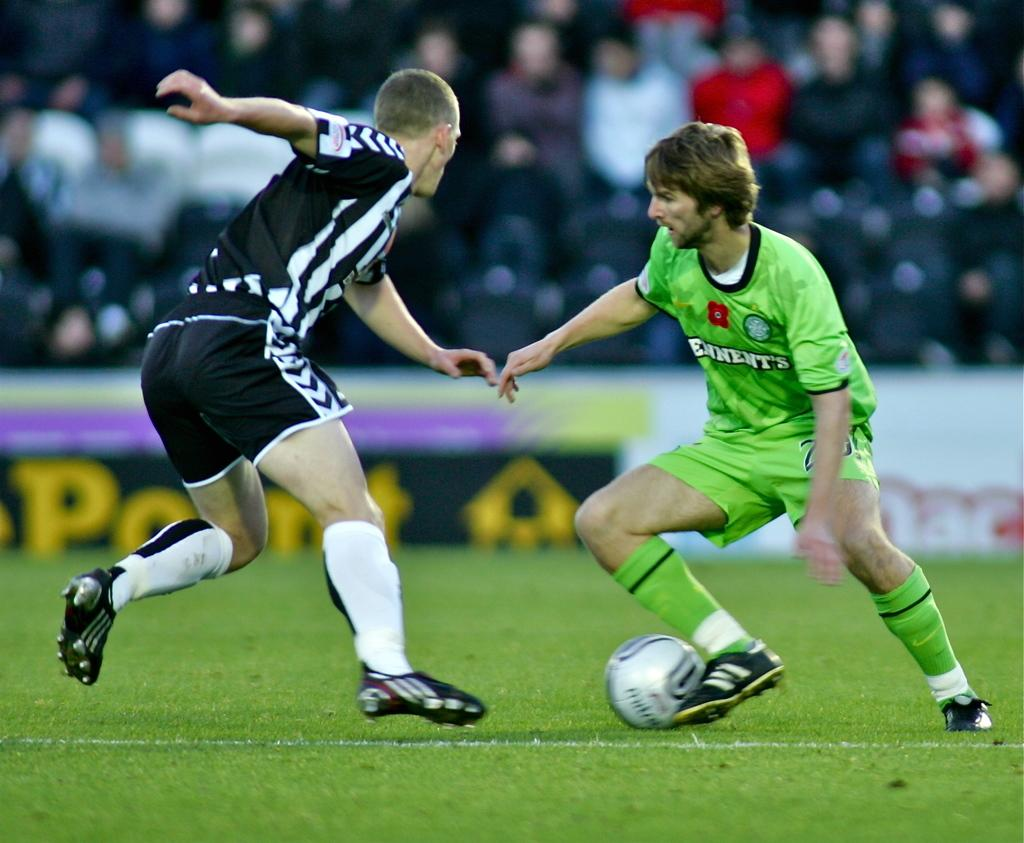How many players are in the image? There are two players in the image. What sport are the players engaged in? The players are playing football. What can be seen in the background of the image? There are spectators in the background of the image. What are the spectators doing? The spectators are watching the game. What type of comparison can be made between the players and the spectators in the image? There is no comparison being made between the players and the spectators in the image; they are simply engaged in different activities related to the football game. 